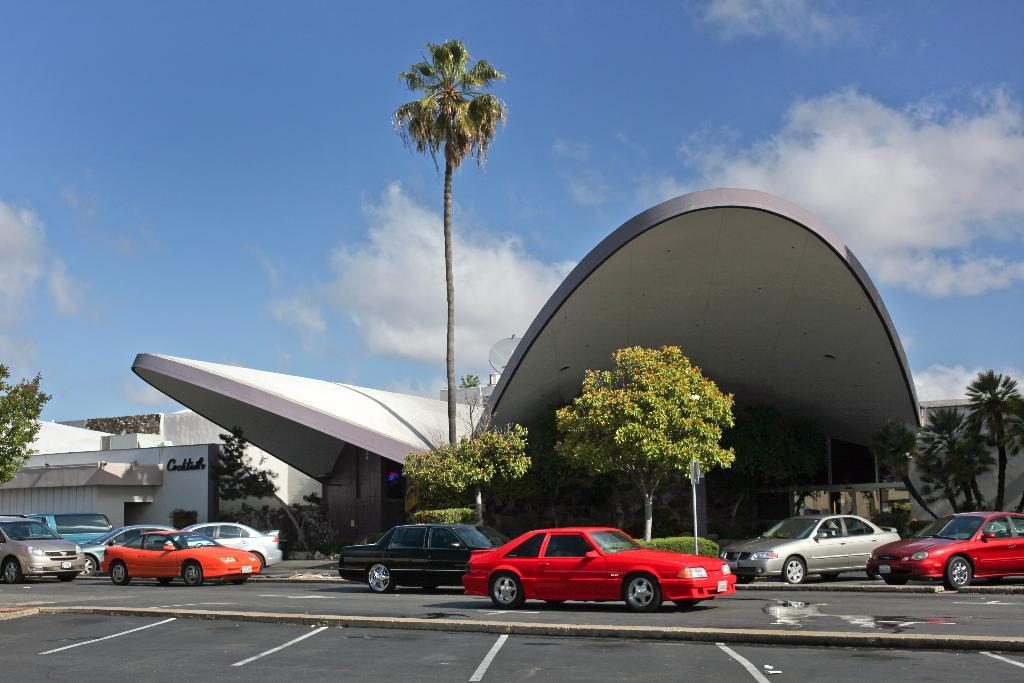What is in the foreground of the image? There is a road in the foreground of the image. What is happening on the road? Objects are moving on the road. What can be seen in the background of the image? There is a building, trees, and the sky visible in the background of the image. What is the condition of the sky in the image? The sky is visible in the background of the image, and there are clouds present. How many boats are visible in the image? There are no boats present in the image. What type of mine is located near the building in the image? There is no mine present in the image; it features a road, objects moving on the road, a building, trees, and the sky. 